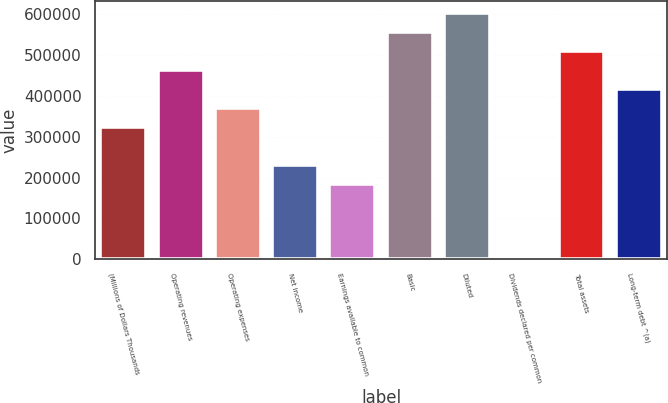<chart> <loc_0><loc_0><loc_500><loc_500><bar_chart><fcel>(Millions of Dollars Thousands<fcel>Operating revenues<fcel>Operating expenses<fcel>Net income<fcel>Earnings available to common<fcel>Basic<fcel>Diluted<fcel>Dividends declared per common<fcel>Total assets<fcel>Long-term debt ^(a)<nl><fcel>324374<fcel>463391<fcel>370713<fcel>231696<fcel>185357<fcel>556069<fcel>602408<fcel>1<fcel>509730<fcel>417052<nl></chart> 